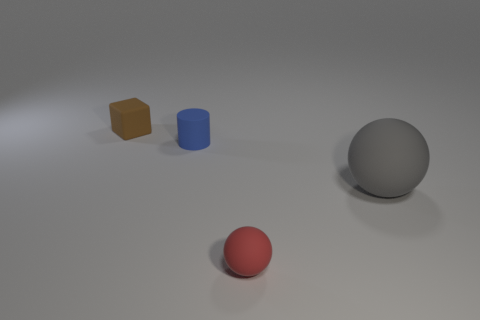Is there anything else that has the same size as the gray thing?
Keep it short and to the point. No. Is the number of tiny blue things behind the brown rubber cube the same as the number of small brown things that are left of the gray rubber ball?
Your response must be concise. No. Is there a blue thing left of the cylinder that is behind the gray sphere?
Provide a succinct answer. No. The gray rubber thing is what shape?
Give a very brief answer. Sphere. There is a object that is behind the blue thing behind the large gray matte ball; what is its size?
Provide a succinct answer. Small. What size is the matte object on the left side of the blue object?
Your answer should be compact. Small. Is the number of blue rubber objects that are in front of the small red sphere less than the number of tiny cubes on the left side of the cylinder?
Provide a short and direct response. Yes. The cube is what color?
Your response must be concise. Brown. What is the shape of the object to the right of the ball that is on the left side of the matte object that is on the right side of the small matte sphere?
Offer a terse response. Sphere. What material is the small thing that is in front of the cylinder?
Provide a succinct answer. Rubber. 